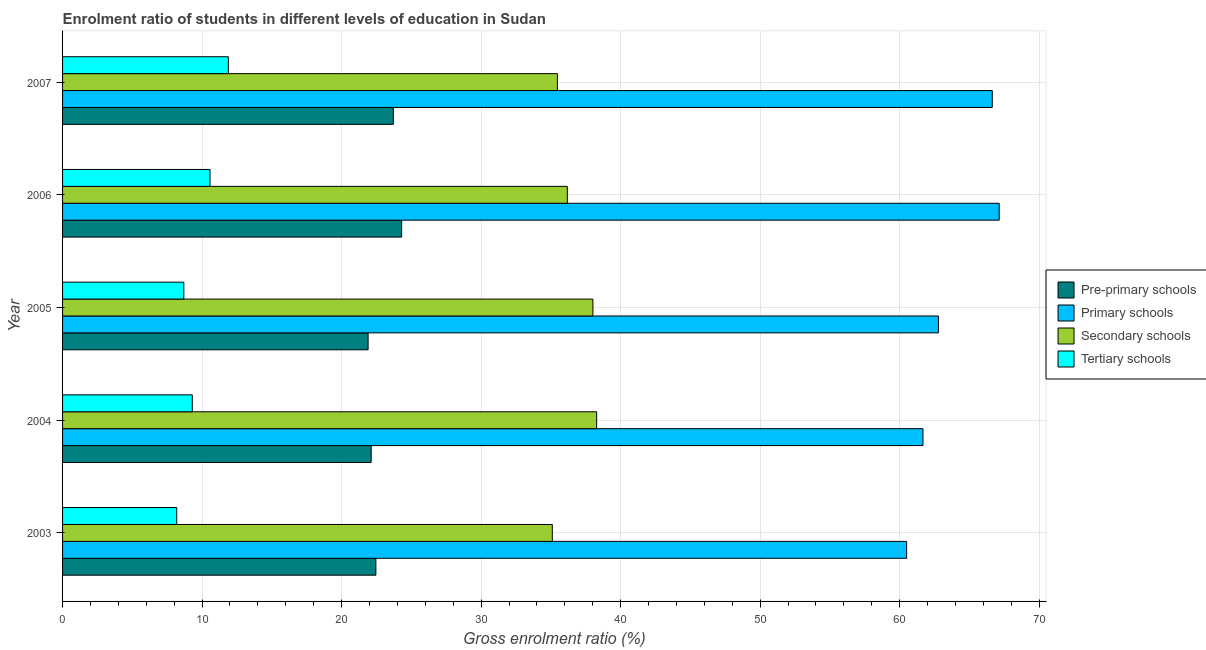How many groups of bars are there?
Make the answer very short. 5. What is the label of the 5th group of bars from the top?
Give a very brief answer. 2003. In how many cases, is the number of bars for a given year not equal to the number of legend labels?
Give a very brief answer. 0. What is the gross enrolment ratio in secondary schools in 2005?
Provide a short and direct response. 38.01. Across all years, what is the maximum gross enrolment ratio in tertiary schools?
Offer a terse response. 11.88. Across all years, what is the minimum gross enrolment ratio in pre-primary schools?
Provide a short and direct response. 21.9. What is the total gross enrolment ratio in primary schools in the graph?
Your answer should be very brief. 318.71. What is the difference between the gross enrolment ratio in tertiary schools in 2005 and that in 2006?
Provide a succinct answer. -1.88. What is the difference between the gross enrolment ratio in tertiary schools in 2007 and the gross enrolment ratio in primary schools in 2006?
Offer a terse response. -55.25. What is the average gross enrolment ratio in secondary schools per year?
Make the answer very short. 36.61. In the year 2003, what is the difference between the gross enrolment ratio in tertiary schools and gross enrolment ratio in primary schools?
Make the answer very short. -52.32. In how many years, is the gross enrolment ratio in tertiary schools greater than 40 %?
Make the answer very short. 0. What is the ratio of the gross enrolment ratio in primary schools in 2003 to that in 2007?
Make the answer very short. 0.91. Is the gross enrolment ratio in primary schools in 2003 less than that in 2006?
Your answer should be compact. Yes. Is the difference between the gross enrolment ratio in primary schools in 2005 and 2006 greater than the difference between the gross enrolment ratio in secondary schools in 2005 and 2006?
Your answer should be very brief. No. What is the difference between the highest and the second highest gross enrolment ratio in tertiary schools?
Keep it short and to the point. 1.32. What is the difference between the highest and the lowest gross enrolment ratio in pre-primary schools?
Offer a very short reply. 2.4. In how many years, is the gross enrolment ratio in primary schools greater than the average gross enrolment ratio in primary schools taken over all years?
Offer a terse response. 2. Is the sum of the gross enrolment ratio in pre-primary schools in 2003 and 2004 greater than the maximum gross enrolment ratio in primary schools across all years?
Offer a terse response. No. What does the 3rd bar from the top in 2006 represents?
Ensure brevity in your answer.  Primary schools. What does the 2nd bar from the bottom in 2007 represents?
Provide a succinct answer. Primary schools. Is it the case that in every year, the sum of the gross enrolment ratio in pre-primary schools and gross enrolment ratio in primary schools is greater than the gross enrolment ratio in secondary schools?
Make the answer very short. Yes. How many bars are there?
Give a very brief answer. 20. What is the difference between two consecutive major ticks on the X-axis?
Ensure brevity in your answer.  10. Where does the legend appear in the graph?
Your answer should be very brief. Center right. How many legend labels are there?
Keep it short and to the point. 4. How are the legend labels stacked?
Provide a succinct answer. Vertical. What is the title of the graph?
Keep it short and to the point. Enrolment ratio of students in different levels of education in Sudan. What is the label or title of the X-axis?
Your answer should be very brief. Gross enrolment ratio (%). What is the Gross enrolment ratio (%) in Pre-primary schools in 2003?
Offer a very short reply. 22.46. What is the Gross enrolment ratio (%) of Primary schools in 2003?
Your answer should be very brief. 60.5. What is the Gross enrolment ratio (%) in Secondary schools in 2003?
Provide a succinct answer. 35.1. What is the Gross enrolment ratio (%) of Tertiary schools in 2003?
Your response must be concise. 8.18. What is the Gross enrolment ratio (%) in Pre-primary schools in 2004?
Offer a very short reply. 22.12. What is the Gross enrolment ratio (%) of Primary schools in 2004?
Your answer should be compact. 61.67. What is the Gross enrolment ratio (%) in Secondary schools in 2004?
Offer a very short reply. 38.28. What is the Gross enrolment ratio (%) of Tertiary schools in 2004?
Ensure brevity in your answer.  9.3. What is the Gross enrolment ratio (%) of Pre-primary schools in 2005?
Offer a very short reply. 21.9. What is the Gross enrolment ratio (%) in Primary schools in 2005?
Give a very brief answer. 62.78. What is the Gross enrolment ratio (%) in Secondary schools in 2005?
Make the answer very short. 38.01. What is the Gross enrolment ratio (%) of Tertiary schools in 2005?
Your response must be concise. 8.69. What is the Gross enrolment ratio (%) of Pre-primary schools in 2006?
Provide a short and direct response. 24.3. What is the Gross enrolment ratio (%) in Primary schools in 2006?
Your answer should be compact. 67.13. What is the Gross enrolment ratio (%) in Secondary schools in 2006?
Offer a terse response. 36.18. What is the Gross enrolment ratio (%) of Tertiary schools in 2006?
Offer a terse response. 10.57. What is the Gross enrolment ratio (%) in Pre-primary schools in 2007?
Your answer should be very brief. 23.71. What is the Gross enrolment ratio (%) in Primary schools in 2007?
Keep it short and to the point. 66.64. What is the Gross enrolment ratio (%) in Secondary schools in 2007?
Give a very brief answer. 35.47. What is the Gross enrolment ratio (%) in Tertiary schools in 2007?
Your answer should be very brief. 11.88. Across all years, what is the maximum Gross enrolment ratio (%) of Pre-primary schools?
Provide a short and direct response. 24.3. Across all years, what is the maximum Gross enrolment ratio (%) in Primary schools?
Offer a terse response. 67.13. Across all years, what is the maximum Gross enrolment ratio (%) in Secondary schools?
Offer a terse response. 38.28. Across all years, what is the maximum Gross enrolment ratio (%) of Tertiary schools?
Provide a succinct answer. 11.88. Across all years, what is the minimum Gross enrolment ratio (%) of Pre-primary schools?
Provide a short and direct response. 21.9. Across all years, what is the minimum Gross enrolment ratio (%) in Primary schools?
Offer a terse response. 60.5. Across all years, what is the minimum Gross enrolment ratio (%) of Secondary schools?
Give a very brief answer. 35.1. Across all years, what is the minimum Gross enrolment ratio (%) of Tertiary schools?
Offer a terse response. 8.18. What is the total Gross enrolment ratio (%) in Pre-primary schools in the graph?
Offer a terse response. 114.48. What is the total Gross enrolment ratio (%) of Primary schools in the graph?
Offer a terse response. 318.71. What is the total Gross enrolment ratio (%) of Secondary schools in the graph?
Your answer should be very brief. 183.04. What is the total Gross enrolment ratio (%) in Tertiary schools in the graph?
Your response must be concise. 48.62. What is the difference between the Gross enrolment ratio (%) in Pre-primary schools in 2003 and that in 2004?
Keep it short and to the point. 0.34. What is the difference between the Gross enrolment ratio (%) in Primary schools in 2003 and that in 2004?
Offer a very short reply. -1.17. What is the difference between the Gross enrolment ratio (%) of Secondary schools in 2003 and that in 2004?
Your answer should be compact. -3.18. What is the difference between the Gross enrolment ratio (%) of Tertiary schools in 2003 and that in 2004?
Give a very brief answer. -1.12. What is the difference between the Gross enrolment ratio (%) in Pre-primary schools in 2003 and that in 2005?
Ensure brevity in your answer.  0.56. What is the difference between the Gross enrolment ratio (%) in Primary schools in 2003 and that in 2005?
Your answer should be compact. -2.28. What is the difference between the Gross enrolment ratio (%) of Secondary schools in 2003 and that in 2005?
Ensure brevity in your answer.  -2.91. What is the difference between the Gross enrolment ratio (%) of Tertiary schools in 2003 and that in 2005?
Make the answer very short. -0.51. What is the difference between the Gross enrolment ratio (%) in Pre-primary schools in 2003 and that in 2006?
Keep it short and to the point. -1.85. What is the difference between the Gross enrolment ratio (%) of Primary schools in 2003 and that in 2006?
Your answer should be very brief. -6.63. What is the difference between the Gross enrolment ratio (%) of Secondary schools in 2003 and that in 2006?
Provide a succinct answer. -1.08. What is the difference between the Gross enrolment ratio (%) in Tertiary schools in 2003 and that in 2006?
Keep it short and to the point. -2.39. What is the difference between the Gross enrolment ratio (%) in Pre-primary schools in 2003 and that in 2007?
Provide a succinct answer. -1.25. What is the difference between the Gross enrolment ratio (%) of Primary schools in 2003 and that in 2007?
Give a very brief answer. -6.14. What is the difference between the Gross enrolment ratio (%) of Secondary schools in 2003 and that in 2007?
Your answer should be compact. -0.36. What is the difference between the Gross enrolment ratio (%) of Tertiary schools in 2003 and that in 2007?
Offer a terse response. -3.7. What is the difference between the Gross enrolment ratio (%) in Pre-primary schools in 2004 and that in 2005?
Your answer should be very brief. 0.22. What is the difference between the Gross enrolment ratio (%) of Primary schools in 2004 and that in 2005?
Offer a very short reply. -1.11. What is the difference between the Gross enrolment ratio (%) of Secondary schools in 2004 and that in 2005?
Make the answer very short. 0.27. What is the difference between the Gross enrolment ratio (%) in Tertiary schools in 2004 and that in 2005?
Your response must be concise. 0.61. What is the difference between the Gross enrolment ratio (%) in Pre-primary schools in 2004 and that in 2006?
Your answer should be compact. -2.18. What is the difference between the Gross enrolment ratio (%) in Primary schools in 2004 and that in 2006?
Your answer should be compact. -5.46. What is the difference between the Gross enrolment ratio (%) of Secondary schools in 2004 and that in 2006?
Offer a terse response. 2.1. What is the difference between the Gross enrolment ratio (%) of Tertiary schools in 2004 and that in 2006?
Keep it short and to the point. -1.27. What is the difference between the Gross enrolment ratio (%) in Pre-primary schools in 2004 and that in 2007?
Give a very brief answer. -1.59. What is the difference between the Gross enrolment ratio (%) in Primary schools in 2004 and that in 2007?
Provide a succinct answer. -4.97. What is the difference between the Gross enrolment ratio (%) of Secondary schools in 2004 and that in 2007?
Your answer should be very brief. 2.81. What is the difference between the Gross enrolment ratio (%) of Tertiary schools in 2004 and that in 2007?
Provide a succinct answer. -2.59. What is the difference between the Gross enrolment ratio (%) of Pre-primary schools in 2005 and that in 2006?
Your answer should be very brief. -2.4. What is the difference between the Gross enrolment ratio (%) in Primary schools in 2005 and that in 2006?
Your answer should be very brief. -4.36. What is the difference between the Gross enrolment ratio (%) in Secondary schools in 2005 and that in 2006?
Provide a short and direct response. 1.83. What is the difference between the Gross enrolment ratio (%) of Tertiary schools in 2005 and that in 2006?
Offer a very short reply. -1.88. What is the difference between the Gross enrolment ratio (%) in Pre-primary schools in 2005 and that in 2007?
Keep it short and to the point. -1.81. What is the difference between the Gross enrolment ratio (%) of Primary schools in 2005 and that in 2007?
Your answer should be very brief. -3.86. What is the difference between the Gross enrolment ratio (%) in Secondary schools in 2005 and that in 2007?
Ensure brevity in your answer.  2.55. What is the difference between the Gross enrolment ratio (%) in Tertiary schools in 2005 and that in 2007?
Your response must be concise. -3.19. What is the difference between the Gross enrolment ratio (%) of Pre-primary schools in 2006 and that in 2007?
Give a very brief answer. 0.59. What is the difference between the Gross enrolment ratio (%) of Primary schools in 2006 and that in 2007?
Your answer should be very brief. 0.5. What is the difference between the Gross enrolment ratio (%) in Secondary schools in 2006 and that in 2007?
Your answer should be compact. 0.71. What is the difference between the Gross enrolment ratio (%) of Tertiary schools in 2006 and that in 2007?
Your answer should be compact. -1.32. What is the difference between the Gross enrolment ratio (%) in Pre-primary schools in 2003 and the Gross enrolment ratio (%) in Primary schools in 2004?
Your answer should be very brief. -39.21. What is the difference between the Gross enrolment ratio (%) of Pre-primary schools in 2003 and the Gross enrolment ratio (%) of Secondary schools in 2004?
Ensure brevity in your answer.  -15.82. What is the difference between the Gross enrolment ratio (%) in Pre-primary schools in 2003 and the Gross enrolment ratio (%) in Tertiary schools in 2004?
Provide a succinct answer. 13.16. What is the difference between the Gross enrolment ratio (%) of Primary schools in 2003 and the Gross enrolment ratio (%) of Secondary schools in 2004?
Your answer should be compact. 22.22. What is the difference between the Gross enrolment ratio (%) of Primary schools in 2003 and the Gross enrolment ratio (%) of Tertiary schools in 2004?
Ensure brevity in your answer.  51.2. What is the difference between the Gross enrolment ratio (%) in Secondary schools in 2003 and the Gross enrolment ratio (%) in Tertiary schools in 2004?
Offer a very short reply. 25.8. What is the difference between the Gross enrolment ratio (%) of Pre-primary schools in 2003 and the Gross enrolment ratio (%) of Primary schools in 2005?
Your answer should be very brief. -40.32. What is the difference between the Gross enrolment ratio (%) in Pre-primary schools in 2003 and the Gross enrolment ratio (%) in Secondary schools in 2005?
Your answer should be very brief. -15.56. What is the difference between the Gross enrolment ratio (%) of Pre-primary schools in 2003 and the Gross enrolment ratio (%) of Tertiary schools in 2005?
Your answer should be very brief. 13.76. What is the difference between the Gross enrolment ratio (%) in Primary schools in 2003 and the Gross enrolment ratio (%) in Secondary schools in 2005?
Your answer should be very brief. 22.49. What is the difference between the Gross enrolment ratio (%) in Primary schools in 2003 and the Gross enrolment ratio (%) in Tertiary schools in 2005?
Your answer should be compact. 51.81. What is the difference between the Gross enrolment ratio (%) of Secondary schools in 2003 and the Gross enrolment ratio (%) of Tertiary schools in 2005?
Make the answer very short. 26.41. What is the difference between the Gross enrolment ratio (%) of Pre-primary schools in 2003 and the Gross enrolment ratio (%) of Primary schools in 2006?
Provide a short and direct response. -44.68. What is the difference between the Gross enrolment ratio (%) in Pre-primary schools in 2003 and the Gross enrolment ratio (%) in Secondary schools in 2006?
Your answer should be very brief. -13.72. What is the difference between the Gross enrolment ratio (%) in Pre-primary schools in 2003 and the Gross enrolment ratio (%) in Tertiary schools in 2006?
Your answer should be very brief. 11.89. What is the difference between the Gross enrolment ratio (%) in Primary schools in 2003 and the Gross enrolment ratio (%) in Secondary schools in 2006?
Provide a succinct answer. 24.32. What is the difference between the Gross enrolment ratio (%) of Primary schools in 2003 and the Gross enrolment ratio (%) of Tertiary schools in 2006?
Your answer should be very brief. 49.93. What is the difference between the Gross enrolment ratio (%) of Secondary schools in 2003 and the Gross enrolment ratio (%) of Tertiary schools in 2006?
Your answer should be compact. 24.53. What is the difference between the Gross enrolment ratio (%) in Pre-primary schools in 2003 and the Gross enrolment ratio (%) in Primary schools in 2007?
Offer a very short reply. -44.18. What is the difference between the Gross enrolment ratio (%) of Pre-primary schools in 2003 and the Gross enrolment ratio (%) of Secondary schools in 2007?
Your answer should be very brief. -13.01. What is the difference between the Gross enrolment ratio (%) of Pre-primary schools in 2003 and the Gross enrolment ratio (%) of Tertiary schools in 2007?
Your answer should be compact. 10.57. What is the difference between the Gross enrolment ratio (%) of Primary schools in 2003 and the Gross enrolment ratio (%) of Secondary schools in 2007?
Make the answer very short. 25.03. What is the difference between the Gross enrolment ratio (%) of Primary schools in 2003 and the Gross enrolment ratio (%) of Tertiary schools in 2007?
Your answer should be very brief. 48.62. What is the difference between the Gross enrolment ratio (%) in Secondary schools in 2003 and the Gross enrolment ratio (%) in Tertiary schools in 2007?
Provide a short and direct response. 23.22. What is the difference between the Gross enrolment ratio (%) of Pre-primary schools in 2004 and the Gross enrolment ratio (%) of Primary schools in 2005?
Your response must be concise. -40.66. What is the difference between the Gross enrolment ratio (%) in Pre-primary schools in 2004 and the Gross enrolment ratio (%) in Secondary schools in 2005?
Your answer should be compact. -15.89. What is the difference between the Gross enrolment ratio (%) in Pre-primary schools in 2004 and the Gross enrolment ratio (%) in Tertiary schools in 2005?
Your answer should be very brief. 13.43. What is the difference between the Gross enrolment ratio (%) of Primary schools in 2004 and the Gross enrolment ratio (%) of Secondary schools in 2005?
Your answer should be compact. 23.66. What is the difference between the Gross enrolment ratio (%) of Primary schools in 2004 and the Gross enrolment ratio (%) of Tertiary schools in 2005?
Your answer should be very brief. 52.98. What is the difference between the Gross enrolment ratio (%) in Secondary schools in 2004 and the Gross enrolment ratio (%) in Tertiary schools in 2005?
Provide a succinct answer. 29.59. What is the difference between the Gross enrolment ratio (%) in Pre-primary schools in 2004 and the Gross enrolment ratio (%) in Primary schools in 2006?
Offer a very short reply. -45.01. What is the difference between the Gross enrolment ratio (%) of Pre-primary schools in 2004 and the Gross enrolment ratio (%) of Secondary schools in 2006?
Offer a very short reply. -14.06. What is the difference between the Gross enrolment ratio (%) in Pre-primary schools in 2004 and the Gross enrolment ratio (%) in Tertiary schools in 2006?
Provide a short and direct response. 11.55. What is the difference between the Gross enrolment ratio (%) in Primary schools in 2004 and the Gross enrolment ratio (%) in Secondary schools in 2006?
Provide a short and direct response. 25.49. What is the difference between the Gross enrolment ratio (%) in Primary schools in 2004 and the Gross enrolment ratio (%) in Tertiary schools in 2006?
Keep it short and to the point. 51.1. What is the difference between the Gross enrolment ratio (%) in Secondary schools in 2004 and the Gross enrolment ratio (%) in Tertiary schools in 2006?
Provide a succinct answer. 27.71. What is the difference between the Gross enrolment ratio (%) of Pre-primary schools in 2004 and the Gross enrolment ratio (%) of Primary schools in 2007?
Give a very brief answer. -44.52. What is the difference between the Gross enrolment ratio (%) of Pre-primary schools in 2004 and the Gross enrolment ratio (%) of Secondary schools in 2007?
Your response must be concise. -13.35. What is the difference between the Gross enrolment ratio (%) of Pre-primary schools in 2004 and the Gross enrolment ratio (%) of Tertiary schools in 2007?
Keep it short and to the point. 10.23. What is the difference between the Gross enrolment ratio (%) in Primary schools in 2004 and the Gross enrolment ratio (%) in Secondary schools in 2007?
Your response must be concise. 26.2. What is the difference between the Gross enrolment ratio (%) of Primary schools in 2004 and the Gross enrolment ratio (%) of Tertiary schools in 2007?
Your answer should be compact. 49.78. What is the difference between the Gross enrolment ratio (%) of Secondary schools in 2004 and the Gross enrolment ratio (%) of Tertiary schools in 2007?
Keep it short and to the point. 26.4. What is the difference between the Gross enrolment ratio (%) in Pre-primary schools in 2005 and the Gross enrolment ratio (%) in Primary schools in 2006?
Your response must be concise. -45.23. What is the difference between the Gross enrolment ratio (%) of Pre-primary schools in 2005 and the Gross enrolment ratio (%) of Secondary schools in 2006?
Offer a very short reply. -14.28. What is the difference between the Gross enrolment ratio (%) in Pre-primary schools in 2005 and the Gross enrolment ratio (%) in Tertiary schools in 2006?
Give a very brief answer. 11.33. What is the difference between the Gross enrolment ratio (%) of Primary schools in 2005 and the Gross enrolment ratio (%) of Secondary schools in 2006?
Offer a terse response. 26.6. What is the difference between the Gross enrolment ratio (%) of Primary schools in 2005 and the Gross enrolment ratio (%) of Tertiary schools in 2006?
Your response must be concise. 52.21. What is the difference between the Gross enrolment ratio (%) of Secondary schools in 2005 and the Gross enrolment ratio (%) of Tertiary schools in 2006?
Your response must be concise. 27.44. What is the difference between the Gross enrolment ratio (%) of Pre-primary schools in 2005 and the Gross enrolment ratio (%) of Primary schools in 2007?
Provide a succinct answer. -44.74. What is the difference between the Gross enrolment ratio (%) of Pre-primary schools in 2005 and the Gross enrolment ratio (%) of Secondary schools in 2007?
Make the answer very short. -13.57. What is the difference between the Gross enrolment ratio (%) of Pre-primary schools in 2005 and the Gross enrolment ratio (%) of Tertiary schools in 2007?
Keep it short and to the point. 10.01. What is the difference between the Gross enrolment ratio (%) in Primary schools in 2005 and the Gross enrolment ratio (%) in Secondary schools in 2007?
Offer a terse response. 27.31. What is the difference between the Gross enrolment ratio (%) in Primary schools in 2005 and the Gross enrolment ratio (%) in Tertiary schools in 2007?
Offer a very short reply. 50.89. What is the difference between the Gross enrolment ratio (%) of Secondary schools in 2005 and the Gross enrolment ratio (%) of Tertiary schools in 2007?
Ensure brevity in your answer.  26.13. What is the difference between the Gross enrolment ratio (%) of Pre-primary schools in 2006 and the Gross enrolment ratio (%) of Primary schools in 2007?
Give a very brief answer. -42.33. What is the difference between the Gross enrolment ratio (%) in Pre-primary schools in 2006 and the Gross enrolment ratio (%) in Secondary schools in 2007?
Your answer should be compact. -11.16. What is the difference between the Gross enrolment ratio (%) of Pre-primary schools in 2006 and the Gross enrolment ratio (%) of Tertiary schools in 2007?
Your answer should be very brief. 12.42. What is the difference between the Gross enrolment ratio (%) in Primary schools in 2006 and the Gross enrolment ratio (%) in Secondary schools in 2007?
Give a very brief answer. 31.67. What is the difference between the Gross enrolment ratio (%) of Primary schools in 2006 and the Gross enrolment ratio (%) of Tertiary schools in 2007?
Make the answer very short. 55.25. What is the difference between the Gross enrolment ratio (%) in Secondary schools in 2006 and the Gross enrolment ratio (%) in Tertiary schools in 2007?
Give a very brief answer. 24.29. What is the average Gross enrolment ratio (%) in Pre-primary schools per year?
Give a very brief answer. 22.9. What is the average Gross enrolment ratio (%) in Primary schools per year?
Keep it short and to the point. 63.74. What is the average Gross enrolment ratio (%) in Secondary schools per year?
Ensure brevity in your answer.  36.61. What is the average Gross enrolment ratio (%) in Tertiary schools per year?
Ensure brevity in your answer.  9.72. In the year 2003, what is the difference between the Gross enrolment ratio (%) of Pre-primary schools and Gross enrolment ratio (%) of Primary schools?
Offer a terse response. -38.04. In the year 2003, what is the difference between the Gross enrolment ratio (%) in Pre-primary schools and Gross enrolment ratio (%) in Secondary schools?
Ensure brevity in your answer.  -12.65. In the year 2003, what is the difference between the Gross enrolment ratio (%) of Pre-primary schools and Gross enrolment ratio (%) of Tertiary schools?
Offer a very short reply. 14.27. In the year 2003, what is the difference between the Gross enrolment ratio (%) in Primary schools and Gross enrolment ratio (%) in Secondary schools?
Provide a short and direct response. 25.4. In the year 2003, what is the difference between the Gross enrolment ratio (%) in Primary schools and Gross enrolment ratio (%) in Tertiary schools?
Provide a succinct answer. 52.32. In the year 2003, what is the difference between the Gross enrolment ratio (%) in Secondary schools and Gross enrolment ratio (%) in Tertiary schools?
Your answer should be very brief. 26.92. In the year 2004, what is the difference between the Gross enrolment ratio (%) in Pre-primary schools and Gross enrolment ratio (%) in Primary schools?
Your answer should be very brief. -39.55. In the year 2004, what is the difference between the Gross enrolment ratio (%) of Pre-primary schools and Gross enrolment ratio (%) of Secondary schools?
Provide a short and direct response. -16.16. In the year 2004, what is the difference between the Gross enrolment ratio (%) in Pre-primary schools and Gross enrolment ratio (%) in Tertiary schools?
Your answer should be compact. 12.82. In the year 2004, what is the difference between the Gross enrolment ratio (%) of Primary schools and Gross enrolment ratio (%) of Secondary schools?
Make the answer very short. 23.39. In the year 2004, what is the difference between the Gross enrolment ratio (%) in Primary schools and Gross enrolment ratio (%) in Tertiary schools?
Offer a terse response. 52.37. In the year 2004, what is the difference between the Gross enrolment ratio (%) in Secondary schools and Gross enrolment ratio (%) in Tertiary schools?
Make the answer very short. 28.98. In the year 2005, what is the difference between the Gross enrolment ratio (%) in Pre-primary schools and Gross enrolment ratio (%) in Primary schools?
Provide a short and direct response. -40.88. In the year 2005, what is the difference between the Gross enrolment ratio (%) of Pre-primary schools and Gross enrolment ratio (%) of Secondary schools?
Give a very brief answer. -16.11. In the year 2005, what is the difference between the Gross enrolment ratio (%) in Pre-primary schools and Gross enrolment ratio (%) in Tertiary schools?
Your response must be concise. 13.21. In the year 2005, what is the difference between the Gross enrolment ratio (%) in Primary schools and Gross enrolment ratio (%) in Secondary schools?
Your response must be concise. 24.76. In the year 2005, what is the difference between the Gross enrolment ratio (%) of Primary schools and Gross enrolment ratio (%) of Tertiary schools?
Offer a very short reply. 54.08. In the year 2005, what is the difference between the Gross enrolment ratio (%) in Secondary schools and Gross enrolment ratio (%) in Tertiary schools?
Your response must be concise. 29.32. In the year 2006, what is the difference between the Gross enrolment ratio (%) in Pre-primary schools and Gross enrolment ratio (%) in Primary schools?
Your answer should be very brief. -42.83. In the year 2006, what is the difference between the Gross enrolment ratio (%) of Pre-primary schools and Gross enrolment ratio (%) of Secondary schools?
Offer a very short reply. -11.88. In the year 2006, what is the difference between the Gross enrolment ratio (%) of Pre-primary schools and Gross enrolment ratio (%) of Tertiary schools?
Provide a succinct answer. 13.73. In the year 2006, what is the difference between the Gross enrolment ratio (%) of Primary schools and Gross enrolment ratio (%) of Secondary schools?
Your answer should be compact. 30.95. In the year 2006, what is the difference between the Gross enrolment ratio (%) of Primary schools and Gross enrolment ratio (%) of Tertiary schools?
Your response must be concise. 56.56. In the year 2006, what is the difference between the Gross enrolment ratio (%) of Secondary schools and Gross enrolment ratio (%) of Tertiary schools?
Give a very brief answer. 25.61. In the year 2007, what is the difference between the Gross enrolment ratio (%) in Pre-primary schools and Gross enrolment ratio (%) in Primary schools?
Offer a very short reply. -42.93. In the year 2007, what is the difference between the Gross enrolment ratio (%) in Pre-primary schools and Gross enrolment ratio (%) in Secondary schools?
Provide a short and direct response. -11.76. In the year 2007, what is the difference between the Gross enrolment ratio (%) of Pre-primary schools and Gross enrolment ratio (%) of Tertiary schools?
Provide a succinct answer. 11.82. In the year 2007, what is the difference between the Gross enrolment ratio (%) of Primary schools and Gross enrolment ratio (%) of Secondary schools?
Your answer should be very brief. 31.17. In the year 2007, what is the difference between the Gross enrolment ratio (%) in Primary schools and Gross enrolment ratio (%) in Tertiary schools?
Give a very brief answer. 54.75. In the year 2007, what is the difference between the Gross enrolment ratio (%) of Secondary schools and Gross enrolment ratio (%) of Tertiary schools?
Offer a terse response. 23.58. What is the ratio of the Gross enrolment ratio (%) of Pre-primary schools in 2003 to that in 2004?
Give a very brief answer. 1.02. What is the ratio of the Gross enrolment ratio (%) of Primary schools in 2003 to that in 2004?
Your answer should be compact. 0.98. What is the ratio of the Gross enrolment ratio (%) in Secondary schools in 2003 to that in 2004?
Provide a short and direct response. 0.92. What is the ratio of the Gross enrolment ratio (%) of Tertiary schools in 2003 to that in 2004?
Your response must be concise. 0.88. What is the ratio of the Gross enrolment ratio (%) in Pre-primary schools in 2003 to that in 2005?
Keep it short and to the point. 1.03. What is the ratio of the Gross enrolment ratio (%) of Primary schools in 2003 to that in 2005?
Your answer should be compact. 0.96. What is the ratio of the Gross enrolment ratio (%) in Secondary schools in 2003 to that in 2005?
Your answer should be compact. 0.92. What is the ratio of the Gross enrolment ratio (%) in Tertiary schools in 2003 to that in 2005?
Offer a very short reply. 0.94. What is the ratio of the Gross enrolment ratio (%) in Pre-primary schools in 2003 to that in 2006?
Your answer should be very brief. 0.92. What is the ratio of the Gross enrolment ratio (%) of Primary schools in 2003 to that in 2006?
Your response must be concise. 0.9. What is the ratio of the Gross enrolment ratio (%) of Secondary schools in 2003 to that in 2006?
Your response must be concise. 0.97. What is the ratio of the Gross enrolment ratio (%) in Tertiary schools in 2003 to that in 2006?
Make the answer very short. 0.77. What is the ratio of the Gross enrolment ratio (%) of Pre-primary schools in 2003 to that in 2007?
Your response must be concise. 0.95. What is the ratio of the Gross enrolment ratio (%) of Primary schools in 2003 to that in 2007?
Make the answer very short. 0.91. What is the ratio of the Gross enrolment ratio (%) in Tertiary schools in 2003 to that in 2007?
Your response must be concise. 0.69. What is the ratio of the Gross enrolment ratio (%) in Primary schools in 2004 to that in 2005?
Provide a succinct answer. 0.98. What is the ratio of the Gross enrolment ratio (%) of Secondary schools in 2004 to that in 2005?
Offer a terse response. 1.01. What is the ratio of the Gross enrolment ratio (%) in Tertiary schools in 2004 to that in 2005?
Provide a short and direct response. 1.07. What is the ratio of the Gross enrolment ratio (%) of Pre-primary schools in 2004 to that in 2006?
Your answer should be compact. 0.91. What is the ratio of the Gross enrolment ratio (%) in Primary schools in 2004 to that in 2006?
Your response must be concise. 0.92. What is the ratio of the Gross enrolment ratio (%) in Secondary schools in 2004 to that in 2006?
Provide a short and direct response. 1.06. What is the ratio of the Gross enrolment ratio (%) in Tertiary schools in 2004 to that in 2006?
Your response must be concise. 0.88. What is the ratio of the Gross enrolment ratio (%) in Pre-primary schools in 2004 to that in 2007?
Make the answer very short. 0.93. What is the ratio of the Gross enrolment ratio (%) in Primary schools in 2004 to that in 2007?
Offer a terse response. 0.93. What is the ratio of the Gross enrolment ratio (%) of Secondary schools in 2004 to that in 2007?
Your response must be concise. 1.08. What is the ratio of the Gross enrolment ratio (%) of Tertiary schools in 2004 to that in 2007?
Your answer should be very brief. 0.78. What is the ratio of the Gross enrolment ratio (%) of Pre-primary schools in 2005 to that in 2006?
Provide a short and direct response. 0.9. What is the ratio of the Gross enrolment ratio (%) in Primary schools in 2005 to that in 2006?
Offer a terse response. 0.94. What is the ratio of the Gross enrolment ratio (%) of Secondary schools in 2005 to that in 2006?
Make the answer very short. 1.05. What is the ratio of the Gross enrolment ratio (%) in Tertiary schools in 2005 to that in 2006?
Provide a short and direct response. 0.82. What is the ratio of the Gross enrolment ratio (%) of Pre-primary schools in 2005 to that in 2007?
Your response must be concise. 0.92. What is the ratio of the Gross enrolment ratio (%) of Primary schools in 2005 to that in 2007?
Offer a very short reply. 0.94. What is the ratio of the Gross enrolment ratio (%) of Secondary schools in 2005 to that in 2007?
Offer a very short reply. 1.07. What is the ratio of the Gross enrolment ratio (%) in Tertiary schools in 2005 to that in 2007?
Provide a short and direct response. 0.73. What is the ratio of the Gross enrolment ratio (%) in Pre-primary schools in 2006 to that in 2007?
Make the answer very short. 1.03. What is the ratio of the Gross enrolment ratio (%) in Primary schools in 2006 to that in 2007?
Offer a terse response. 1.01. What is the ratio of the Gross enrolment ratio (%) of Secondary schools in 2006 to that in 2007?
Keep it short and to the point. 1.02. What is the ratio of the Gross enrolment ratio (%) in Tertiary schools in 2006 to that in 2007?
Offer a terse response. 0.89. What is the difference between the highest and the second highest Gross enrolment ratio (%) of Pre-primary schools?
Provide a short and direct response. 0.59. What is the difference between the highest and the second highest Gross enrolment ratio (%) of Primary schools?
Provide a short and direct response. 0.5. What is the difference between the highest and the second highest Gross enrolment ratio (%) of Secondary schools?
Give a very brief answer. 0.27. What is the difference between the highest and the second highest Gross enrolment ratio (%) of Tertiary schools?
Give a very brief answer. 1.32. What is the difference between the highest and the lowest Gross enrolment ratio (%) of Pre-primary schools?
Make the answer very short. 2.4. What is the difference between the highest and the lowest Gross enrolment ratio (%) in Primary schools?
Keep it short and to the point. 6.63. What is the difference between the highest and the lowest Gross enrolment ratio (%) in Secondary schools?
Keep it short and to the point. 3.18. What is the difference between the highest and the lowest Gross enrolment ratio (%) of Tertiary schools?
Offer a terse response. 3.7. 